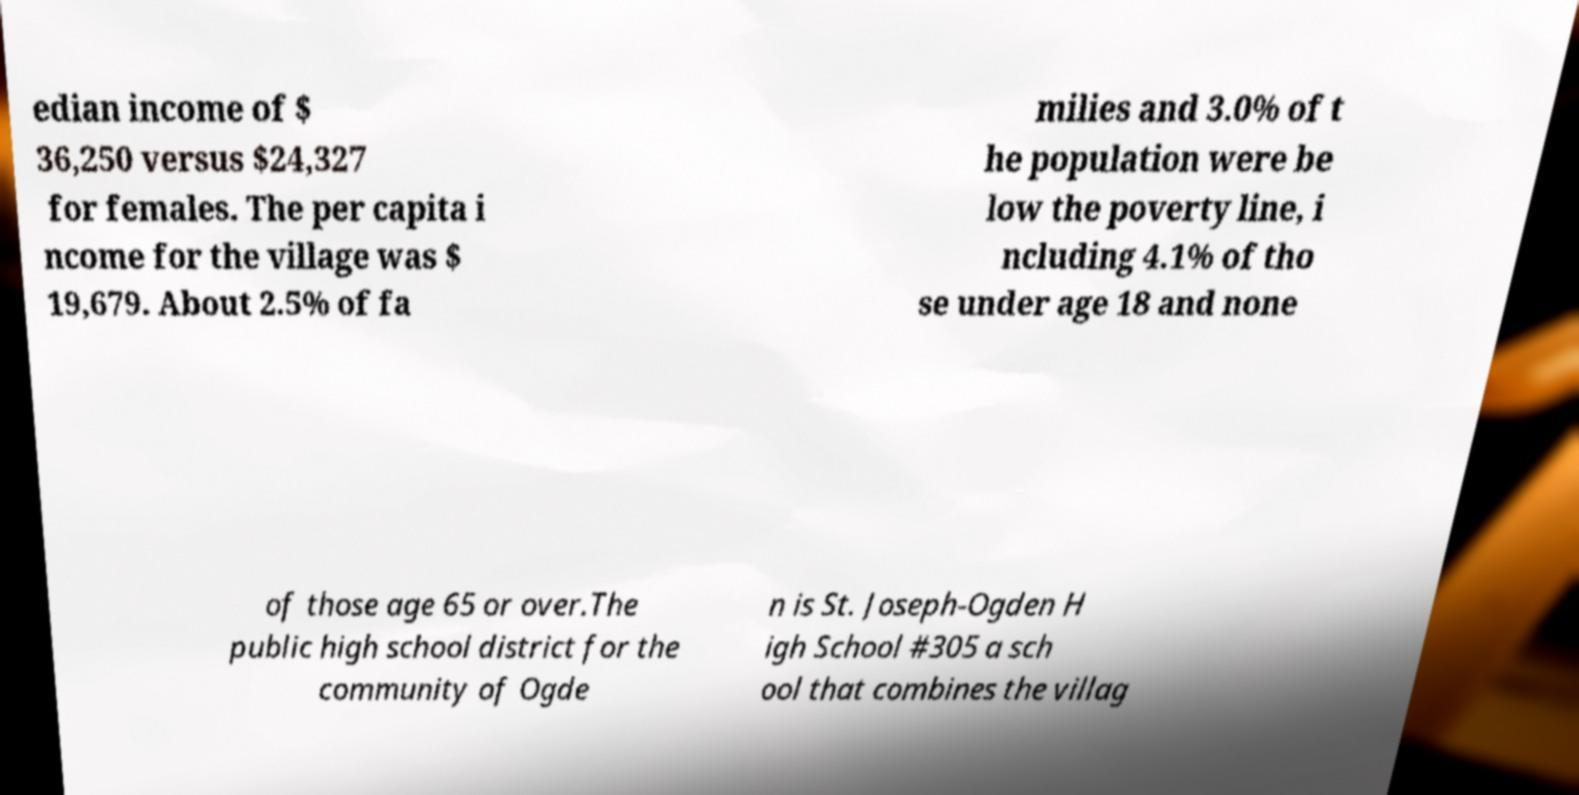For documentation purposes, I need the text within this image transcribed. Could you provide that? edian income of $ 36,250 versus $24,327 for females. The per capita i ncome for the village was $ 19,679. About 2.5% of fa milies and 3.0% of t he population were be low the poverty line, i ncluding 4.1% of tho se under age 18 and none of those age 65 or over.The public high school district for the community of Ogde n is St. Joseph-Ogden H igh School #305 a sch ool that combines the villag 